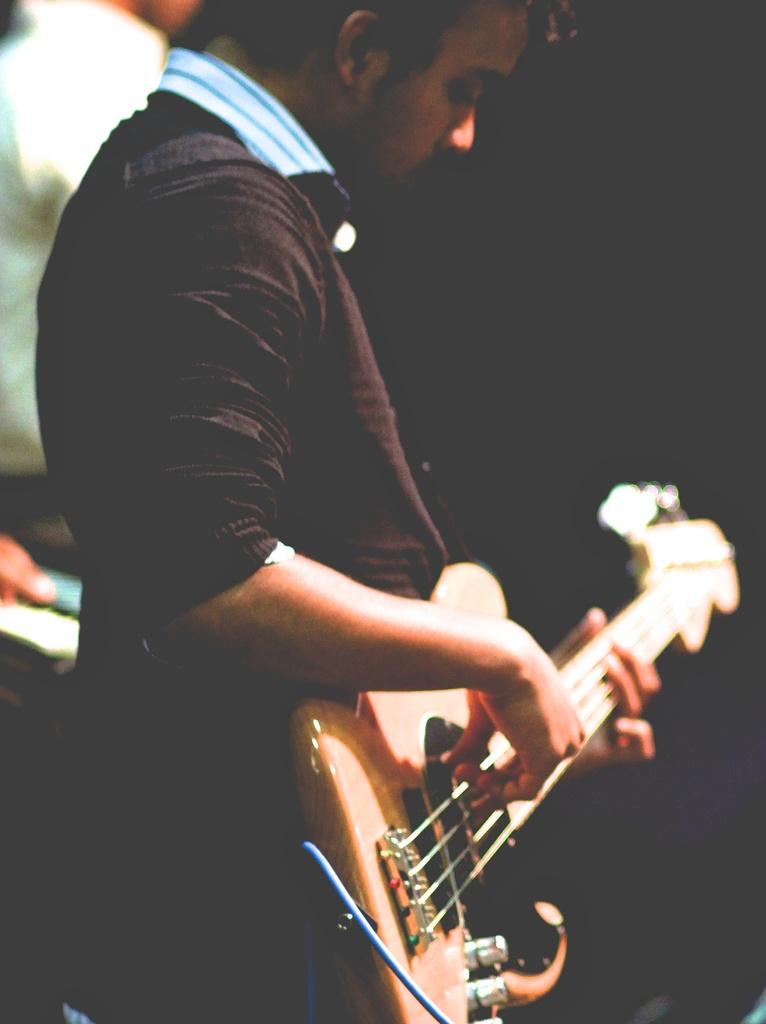What is the main subject of the image? The main subject of the image is a man. What is the man holding in the image? The man is holding a guitar in the image. What type of tax is being discussed in the image? There is no discussion of tax in the image; it features a man holding a guitar. What kind of paste is visible on the guitar in the image? There is no paste visible on the guitar in the image; it is a clean guitar being held by the man. 